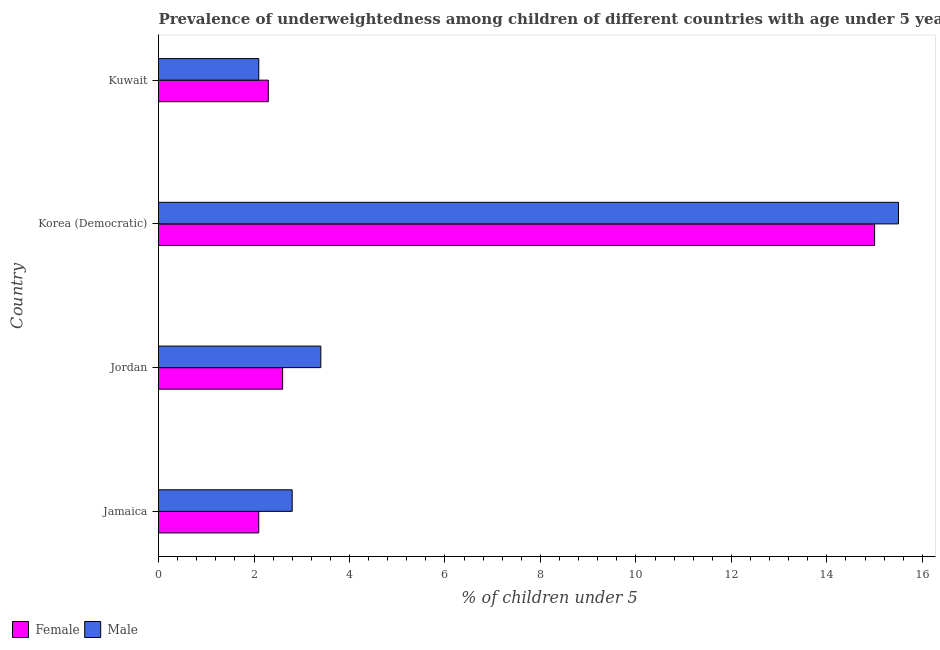How many groups of bars are there?
Offer a very short reply. 4. How many bars are there on the 4th tick from the bottom?
Keep it short and to the point. 2. What is the label of the 1st group of bars from the top?
Give a very brief answer. Kuwait. What is the percentage of underweighted female children in Kuwait?
Provide a succinct answer. 2.3. Across all countries, what is the minimum percentage of underweighted male children?
Give a very brief answer. 2.1. In which country was the percentage of underweighted female children maximum?
Your response must be concise. Korea (Democratic). In which country was the percentage of underweighted female children minimum?
Offer a terse response. Jamaica. What is the total percentage of underweighted female children in the graph?
Your answer should be very brief. 22. What is the difference between the percentage of underweighted male children in Jamaica and that in Kuwait?
Give a very brief answer. 0.7. What is the difference between the percentage of underweighted male children in Jamaica and the percentage of underweighted female children in Jordan?
Your answer should be very brief. 0.2. What is the average percentage of underweighted male children per country?
Offer a very short reply. 5.95. What is the difference between the percentage of underweighted male children and percentage of underweighted female children in Korea (Democratic)?
Ensure brevity in your answer.  0.5. What is the ratio of the percentage of underweighted female children in Jamaica to that in Jordan?
Your answer should be compact. 0.81. Is the percentage of underweighted male children in Jordan less than that in Kuwait?
Ensure brevity in your answer.  No. What is the difference between the highest and the second highest percentage of underweighted female children?
Keep it short and to the point. 12.4. What is the difference between the highest and the lowest percentage of underweighted male children?
Offer a terse response. 13.4. What does the 1st bar from the bottom in Jordan represents?
Your answer should be very brief. Female. How many bars are there?
Keep it short and to the point. 8. What is the difference between two consecutive major ticks on the X-axis?
Give a very brief answer. 2. Are the values on the major ticks of X-axis written in scientific E-notation?
Provide a short and direct response. No. Does the graph contain grids?
Your response must be concise. No. What is the title of the graph?
Provide a short and direct response. Prevalence of underweightedness among children of different countries with age under 5 years. What is the label or title of the X-axis?
Make the answer very short.  % of children under 5. What is the label or title of the Y-axis?
Your answer should be very brief. Country. What is the  % of children under 5 of Female in Jamaica?
Offer a very short reply. 2.1. What is the  % of children under 5 in Male in Jamaica?
Make the answer very short. 2.8. What is the  % of children under 5 of Female in Jordan?
Offer a terse response. 2.6. What is the  % of children under 5 of Male in Jordan?
Offer a terse response. 3.4. What is the  % of children under 5 in Male in Korea (Democratic)?
Your response must be concise. 15.5. What is the  % of children under 5 of Female in Kuwait?
Keep it short and to the point. 2.3. What is the  % of children under 5 of Male in Kuwait?
Provide a succinct answer. 2.1. Across all countries, what is the maximum  % of children under 5 in Female?
Provide a succinct answer. 15. Across all countries, what is the minimum  % of children under 5 of Female?
Keep it short and to the point. 2.1. Across all countries, what is the minimum  % of children under 5 of Male?
Offer a terse response. 2.1. What is the total  % of children under 5 of Male in the graph?
Make the answer very short. 23.8. What is the difference between the  % of children under 5 in Male in Jamaica and that in Jordan?
Make the answer very short. -0.6. What is the difference between the  % of children under 5 in Male in Jamaica and that in Kuwait?
Keep it short and to the point. 0.7. What is the difference between the  % of children under 5 in Male in Jordan and that in Korea (Democratic)?
Ensure brevity in your answer.  -12.1. What is the difference between the  % of children under 5 in Female in Korea (Democratic) and that in Kuwait?
Keep it short and to the point. 12.7. What is the difference between the  % of children under 5 of Female in Jamaica and the  % of children under 5 of Male in Jordan?
Make the answer very short. -1.3. What is the difference between the  % of children under 5 of Female in Jamaica and the  % of children under 5 of Male in Korea (Democratic)?
Provide a short and direct response. -13.4. What is the difference between the  % of children under 5 of Female in Jordan and the  % of children under 5 of Male in Korea (Democratic)?
Offer a very short reply. -12.9. What is the difference between the  % of children under 5 of Female in Jordan and the  % of children under 5 of Male in Kuwait?
Provide a short and direct response. 0.5. What is the difference between the  % of children under 5 of Female in Korea (Democratic) and the  % of children under 5 of Male in Kuwait?
Give a very brief answer. 12.9. What is the average  % of children under 5 in Male per country?
Your answer should be very brief. 5.95. What is the difference between the  % of children under 5 of Female and  % of children under 5 of Male in Jamaica?
Provide a short and direct response. -0.7. What is the difference between the  % of children under 5 of Female and  % of children under 5 of Male in Jordan?
Ensure brevity in your answer.  -0.8. What is the ratio of the  % of children under 5 in Female in Jamaica to that in Jordan?
Keep it short and to the point. 0.81. What is the ratio of the  % of children under 5 of Male in Jamaica to that in Jordan?
Your response must be concise. 0.82. What is the ratio of the  % of children under 5 in Female in Jamaica to that in Korea (Democratic)?
Your answer should be compact. 0.14. What is the ratio of the  % of children under 5 of Male in Jamaica to that in Korea (Democratic)?
Offer a terse response. 0.18. What is the ratio of the  % of children under 5 in Female in Jamaica to that in Kuwait?
Your answer should be very brief. 0.91. What is the ratio of the  % of children under 5 in Female in Jordan to that in Korea (Democratic)?
Your answer should be compact. 0.17. What is the ratio of the  % of children under 5 in Male in Jordan to that in Korea (Democratic)?
Offer a terse response. 0.22. What is the ratio of the  % of children under 5 of Female in Jordan to that in Kuwait?
Offer a very short reply. 1.13. What is the ratio of the  % of children under 5 in Male in Jordan to that in Kuwait?
Offer a terse response. 1.62. What is the ratio of the  % of children under 5 of Female in Korea (Democratic) to that in Kuwait?
Provide a succinct answer. 6.52. What is the ratio of the  % of children under 5 of Male in Korea (Democratic) to that in Kuwait?
Make the answer very short. 7.38. What is the difference between the highest and the second highest  % of children under 5 in Female?
Make the answer very short. 12.4. What is the difference between the highest and the second highest  % of children under 5 of Male?
Ensure brevity in your answer.  12.1. What is the difference between the highest and the lowest  % of children under 5 of Female?
Your answer should be very brief. 12.9. 